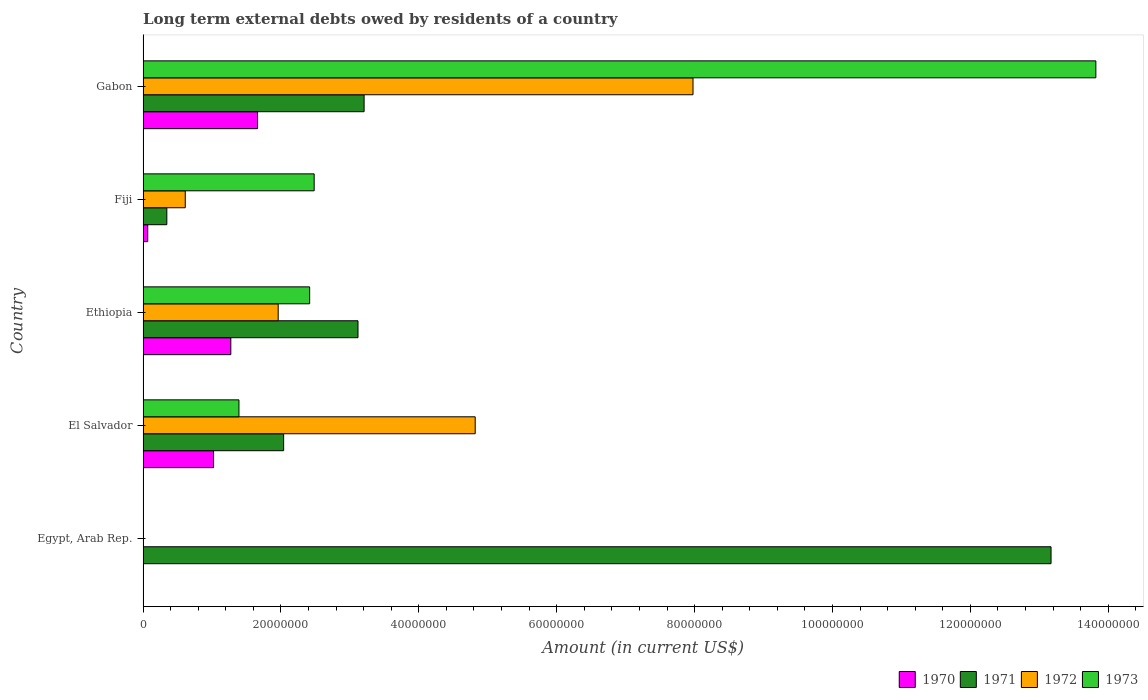Are the number of bars per tick equal to the number of legend labels?
Offer a terse response. No. How many bars are there on the 1st tick from the bottom?
Your answer should be very brief. 1. What is the label of the 4th group of bars from the top?
Provide a short and direct response. El Salvador. What is the amount of long-term external debts owed by residents in 1971 in Gabon?
Make the answer very short. 3.21e+07. Across all countries, what is the maximum amount of long-term external debts owed by residents in 1972?
Ensure brevity in your answer.  7.98e+07. In which country was the amount of long-term external debts owed by residents in 1971 maximum?
Your response must be concise. Egypt, Arab Rep. What is the total amount of long-term external debts owed by residents in 1972 in the graph?
Your answer should be very brief. 1.54e+08. What is the difference between the amount of long-term external debts owed by residents in 1972 in Fiji and that in Gabon?
Make the answer very short. -7.36e+07. What is the difference between the amount of long-term external debts owed by residents in 1971 in El Salvador and the amount of long-term external debts owed by residents in 1972 in Ethiopia?
Ensure brevity in your answer.  7.91e+05. What is the average amount of long-term external debts owed by residents in 1973 per country?
Provide a short and direct response. 4.02e+07. What is the difference between the amount of long-term external debts owed by residents in 1971 and amount of long-term external debts owed by residents in 1973 in Fiji?
Ensure brevity in your answer.  -2.14e+07. In how many countries, is the amount of long-term external debts owed by residents in 1970 greater than 116000000 US$?
Provide a succinct answer. 0. What is the ratio of the amount of long-term external debts owed by residents in 1972 in El Salvador to that in Fiji?
Offer a very short reply. 7.87. Is the difference between the amount of long-term external debts owed by residents in 1971 in Ethiopia and Gabon greater than the difference between the amount of long-term external debts owed by residents in 1973 in Ethiopia and Gabon?
Ensure brevity in your answer.  Yes. What is the difference between the highest and the second highest amount of long-term external debts owed by residents in 1973?
Make the answer very short. 1.13e+08. What is the difference between the highest and the lowest amount of long-term external debts owed by residents in 1973?
Your response must be concise. 1.38e+08. Is the sum of the amount of long-term external debts owed by residents in 1972 in El Salvador and Fiji greater than the maximum amount of long-term external debts owed by residents in 1973 across all countries?
Make the answer very short. No. Is it the case that in every country, the sum of the amount of long-term external debts owed by residents in 1973 and amount of long-term external debts owed by residents in 1971 is greater than the amount of long-term external debts owed by residents in 1972?
Your answer should be compact. No. How many bars are there?
Your response must be concise. 17. How many countries are there in the graph?
Ensure brevity in your answer.  5. Does the graph contain grids?
Offer a terse response. No. Where does the legend appear in the graph?
Your response must be concise. Bottom right. What is the title of the graph?
Provide a succinct answer. Long term external debts owed by residents of a country. Does "1993" appear as one of the legend labels in the graph?
Give a very brief answer. No. What is the Amount (in current US$) of 1971 in Egypt, Arab Rep.?
Provide a succinct answer. 1.32e+08. What is the Amount (in current US$) of 1973 in Egypt, Arab Rep.?
Give a very brief answer. 0. What is the Amount (in current US$) in 1970 in El Salvador?
Your answer should be very brief. 1.02e+07. What is the Amount (in current US$) in 1971 in El Salvador?
Your response must be concise. 2.04e+07. What is the Amount (in current US$) of 1972 in El Salvador?
Your answer should be very brief. 4.82e+07. What is the Amount (in current US$) of 1973 in El Salvador?
Offer a very short reply. 1.39e+07. What is the Amount (in current US$) in 1970 in Ethiopia?
Your response must be concise. 1.27e+07. What is the Amount (in current US$) of 1971 in Ethiopia?
Keep it short and to the point. 3.12e+07. What is the Amount (in current US$) in 1972 in Ethiopia?
Provide a short and direct response. 1.96e+07. What is the Amount (in current US$) in 1973 in Ethiopia?
Your answer should be compact. 2.42e+07. What is the Amount (in current US$) of 1970 in Fiji?
Give a very brief answer. 6.77e+05. What is the Amount (in current US$) in 1971 in Fiji?
Provide a short and direct response. 3.45e+06. What is the Amount (in current US$) in 1972 in Fiji?
Provide a succinct answer. 6.12e+06. What is the Amount (in current US$) of 1973 in Fiji?
Your response must be concise. 2.48e+07. What is the Amount (in current US$) of 1970 in Gabon?
Make the answer very short. 1.66e+07. What is the Amount (in current US$) of 1971 in Gabon?
Your answer should be compact. 3.21e+07. What is the Amount (in current US$) of 1972 in Gabon?
Your answer should be compact. 7.98e+07. What is the Amount (in current US$) of 1973 in Gabon?
Offer a terse response. 1.38e+08. Across all countries, what is the maximum Amount (in current US$) of 1970?
Provide a succinct answer. 1.66e+07. Across all countries, what is the maximum Amount (in current US$) of 1971?
Offer a very short reply. 1.32e+08. Across all countries, what is the maximum Amount (in current US$) in 1972?
Provide a short and direct response. 7.98e+07. Across all countries, what is the maximum Amount (in current US$) in 1973?
Ensure brevity in your answer.  1.38e+08. Across all countries, what is the minimum Amount (in current US$) of 1970?
Provide a short and direct response. 0. Across all countries, what is the minimum Amount (in current US$) of 1971?
Your answer should be very brief. 3.45e+06. What is the total Amount (in current US$) in 1970 in the graph?
Offer a very short reply. 4.02e+07. What is the total Amount (in current US$) of 1971 in the graph?
Your answer should be very brief. 2.19e+08. What is the total Amount (in current US$) in 1972 in the graph?
Give a very brief answer. 1.54e+08. What is the total Amount (in current US$) in 1973 in the graph?
Provide a short and direct response. 2.01e+08. What is the difference between the Amount (in current US$) of 1971 in Egypt, Arab Rep. and that in El Salvador?
Your answer should be very brief. 1.11e+08. What is the difference between the Amount (in current US$) of 1971 in Egypt, Arab Rep. and that in Ethiopia?
Make the answer very short. 1.01e+08. What is the difference between the Amount (in current US$) in 1971 in Egypt, Arab Rep. and that in Fiji?
Offer a terse response. 1.28e+08. What is the difference between the Amount (in current US$) of 1971 in Egypt, Arab Rep. and that in Gabon?
Offer a very short reply. 9.96e+07. What is the difference between the Amount (in current US$) in 1970 in El Salvador and that in Ethiopia?
Provide a succinct answer. -2.50e+06. What is the difference between the Amount (in current US$) of 1971 in El Salvador and that in Ethiopia?
Provide a succinct answer. -1.08e+07. What is the difference between the Amount (in current US$) of 1972 in El Salvador and that in Ethiopia?
Provide a short and direct response. 2.86e+07. What is the difference between the Amount (in current US$) of 1973 in El Salvador and that in Ethiopia?
Make the answer very short. -1.03e+07. What is the difference between the Amount (in current US$) of 1970 in El Salvador and that in Fiji?
Keep it short and to the point. 9.55e+06. What is the difference between the Amount (in current US$) of 1971 in El Salvador and that in Fiji?
Give a very brief answer. 1.69e+07. What is the difference between the Amount (in current US$) of 1972 in El Salvador and that in Fiji?
Your answer should be very brief. 4.21e+07. What is the difference between the Amount (in current US$) of 1973 in El Salvador and that in Fiji?
Your response must be concise. -1.09e+07. What is the difference between the Amount (in current US$) of 1970 in El Salvador and that in Gabon?
Provide a succinct answer. -6.38e+06. What is the difference between the Amount (in current US$) in 1971 in El Salvador and that in Gabon?
Your answer should be very brief. -1.17e+07. What is the difference between the Amount (in current US$) of 1972 in El Salvador and that in Gabon?
Offer a very short reply. -3.16e+07. What is the difference between the Amount (in current US$) in 1973 in El Salvador and that in Gabon?
Offer a very short reply. -1.24e+08. What is the difference between the Amount (in current US$) in 1970 in Ethiopia and that in Fiji?
Provide a short and direct response. 1.20e+07. What is the difference between the Amount (in current US$) in 1971 in Ethiopia and that in Fiji?
Keep it short and to the point. 2.77e+07. What is the difference between the Amount (in current US$) of 1972 in Ethiopia and that in Fiji?
Make the answer very short. 1.35e+07. What is the difference between the Amount (in current US$) in 1973 in Ethiopia and that in Fiji?
Provide a short and direct response. -6.56e+05. What is the difference between the Amount (in current US$) in 1970 in Ethiopia and that in Gabon?
Provide a succinct answer. -3.88e+06. What is the difference between the Amount (in current US$) in 1971 in Ethiopia and that in Gabon?
Make the answer very short. -8.88e+05. What is the difference between the Amount (in current US$) in 1972 in Ethiopia and that in Gabon?
Your answer should be very brief. -6.02e+07. What is the difference between the Amount (in current US$) of 1973 in Ethiopia and that in Gabon?
Make the answer very short. -1.14e+08. What is the difference between the Amount (in current US$) in 1970 in Fiji and that in Gabon?
Give a very brief answer. -1.59e+07. What is the difference between the Amount (in current US$) in 1971 in Fiji and that in Gabon?
Ensure brevity in your answer.  -2.86e+07. What is the difference between the Amount (in current US$) of 1972 in Fiji and that in Gabon?
Provide a succinct answer. -7.36e+07. What is the difference between the Amount (in current US$) of 1973 in Fiji and that in Gabon?
Give a very brief answer. -1.13e+08. What is the difference between the Amount (in current US$) of 1971 in Egypt, Arab Rep. and the Amount (in current US$) of 1972 in El Salvador?
Provide a succinct answer. 8.35e+07. What is the difference between the Amount (in current US$) of 1971 in Egypt, Arab Rep. and the Amount (in current US$) of 1973 in El Salvador?
Make the answer very short. 1.18e+08. What is the difference between the Amount (in current US$) of 1971 in Egypt, Arab Rep. and the Amount (in current US$) of 1972 in Ethiopia?
Provide a short and direct response. 1.12e+08. What is the difference between the Amount (in current US$) of 1971 in Egypt, Arab Rep. and the Amount (in current US$) of 1973 in Ethiopia?
Give a very brief answer. 1.08e+08. What is the difference between the Amount (in current US$) of 1971 in Egypt, Arab Rep. and the Amount (in current US$) of 1972 in Fiji?
Your answer should be compact. 1.26e+08. What is the difference between the Amount (in current US$) in 1971 in Egypt, Arab Rep. and the Amount (in current US$) in 1973 in Fiji?
Your answer should be very brief. 1.07e+08. What is the difference between the Amount (in current US$) in 1971 in Egypt, Arab Rep. and the Amount (in current US$) in 1972 in Gabon?
Ensure brevity in your answer.  5.19e+07. What is the difference between the Amount (in current US$) of 1971 in Egypt, Arab Rep. and the Amount (in current US$) of 1973 in Gabon?
Offer a very short reply. -6.50e+06. What is the difference between the Amount (in current US$) in 1970 in El Salvador and the Amount (in current US$) in 1971 in Ethiopia?
Your answer should be very brief. -2.09e+07. What is the difference between the Amount (in current US$) of 1970 in El Salvador and the Amount (in current US$) of 1972 in Ethiopia?
Your answer should be very brief. -9.37e+06. What is the difference between the Amount (in current US$) of 1970 in El Salvador and the Amount (in current US$) of 1973 in Ethiopia?
Your answer should be compact. -1.39e+07. What is the difference between the Amount (in current US$) in 1971 in El Salvador and the Amount (in current US$) in 1972 in Ethiopia?
Provide a succinct answer. 7.91e+05. What is the difference between the Amount (in current US$) in 1971 in El Salvador and the Amount (in current US$) in 1973 in Ethiopia?
Offer a terse response. -3.77e+06. What is the difference between the Amount (in current US$) in 1972 in El Salvador and the Amount (in current US$) in 1973 in Ethiopia?
Your response must be concise. 2.40e+07. What is the difference between the Amount (in current US$) of 1970 in El Salvador and the Amount (in current US$) of 1971 in Fiji?
Your answer should be very brief. 6.78e+06. What is the difference between the Amount (in current US$) in 1970 in El Salvador and the Amount (in current US$) in 1972 in Fiji?
Make the answer very short. 4.10e+06. What is the difference between the Amount (in current US$) of 1970 in El Salvador and the Amount (in current US$) of 1973 in Fiji?
Your response must be concise. -1.46e+07. What is the difference between the Amount (in current US$) of 1971 in El Salvador and the Amount (in current US$) of 1972 in Fiji?
Keep it short and to the point. 1.43e+07. What is the difference between the Amount (in current US$) of 1971 in El Salvador and the Amount (in current US$) of 1973 in Fiji?
Ensure brevity in your answer.  -4.43e+06. What is the difference between the Amount (in current US$) in 1972 in El Salvador and the Amount (in current US$) in 1973 in Fiji?
Make the answer very short. 2.34e+07. What is the difference between the Amount (in current US$) in 1970 in El Salvador and the Amount (in current US$) in 1971 in Gabon?
Your response must be concise. -2.18e+07. What is the difference between the Amount (in current US$) of 1970 in El Salvador and the Amount (in current US$) of 1972 in Gabon?
Provide a short and direct response. -6.95e+07. What is the difference between the Amount (in current US$) of 1970 in El Salvador and the Amount (in current US$) of 1973 in Gabon?
Ensure brevity in your answer.  -1.28e+08. What is the difference between the Amount (in current US$) in 1971 in El Salvador and the Amount (in current US$) in 1972 in Gabon?
Provide a succinct answer. -5.94e+07. What is the difference between the Amount (in current US$) of 1971 in El Salvador and the Amount (in current US$) of 1973 in Gabon?
Offer a very short reply. -1.18e+08. What is the difference between the Amount (in current US$) of 1972 in El Salvador and the Amount (in current US$) of 1973 in Gabon?
Provide a short and direct response. -9.00e+07. What is the difference between the Amount (in current US$) in 1970 in Ethiopia and the Amount (in current US$) in 1971 in Fiji?
Provide a short and direct response. 9.28e+06. What is the difference between the Amount (in current US$) in 1970 in Ethiopia and the Amount (in current US$) in 1972 in Fiji?
Offer a terse response. 6.61e+06. What is the difference between the Amount (in current US$) in 1970 in Ethiopia and the Amount (in current US$) in 1973 in Fiji?
Keep it short and to the point. -1.21e+07. What is the difference between the Amount (in current US$) in 1971 in Ethiopia and the Amount (in current US$) in 1972 in Fiji?
Give a very brief answer. 2.51e+07. What is the difference between the Amount (in current US$) of 1971 in Ethiopia and the Amount (in current US$) of 1973 in Fiji?
Provide a short and direct response. 6.36e+06. What is the difference between the Amount (in current US$) in 1972 in Ethiopia and the Amount (in current US$) in 1973 in Fiji?
Your answer should be very brief. -5.22e+06. What is the difference between the Amount (in current US$) in 1970 in Ethiopia and the Amount (in current US$) in 1971 in Gabon?
Ensure brevity in your answer.  -1.93e+07. What is the difference between the Amount (in current US$) of 1970 in Ethiopia and the Amount (in current US$) of 1972 in Gabon?
Offer a terse response. -6.70e+07. What is the difference between the Amount (in current US$) in 1970 in Ethiopia and the Amount (in current US$) in 1973 in Gabon?
Make the answer very short. -1.25e+08. What is the difference between the Amount (in current US$) of 1971 in Ethiopia and the Amount (in current US$) of 1972 in Gabon?
Keep it short and to the point. -4.86e+07. What is the difference between the Amount (in current US$) of 1971 in Ethiopia and the Amount (in current US$) of 1973 in Gabon?
Your answer should be compact. -1.07e+08. What is the difference between the Amount (in current US$) in 1972 in Ethiopia and the Amount (in current US$) in 1973 in Gabon?
Your response must be concise. -1.19e+08. What is the difference between the Amount (in current US$) of 1970 in Fiji and the Amount (in current US$) of 1971 in Gabon?
Keep it short and to the point. -3.14e+07. What is the difference between the Amount (in current US$) of 1970 in Fiji and the Amount (in current US$) of 1972 in Gabon?
Offer a very short reply. -7.91e+07. What is the difference between the Amount (in current US$) of 1970 in Fiji and the Amount (in current US$) of 1973 in Gabon?
Keep it short and to the point. -1.38e+08. What is the difference between the Amount (in current US$) in 1971 in Fiji and the Amount (in current US$) in 1972 in Gabon?
Keep it short and to the point. -7.63e+07. What is the difference between the Amount (in current US$) of 1971 in Fiji and the Amount (in current US$) of 1973 in Gabon?
Keep it short and to the point. -1.35e+08. What is the difference between the Amount (in current US$) in 1972 in Fiji and the Amount (in current US$) in 1973 in Gabon?
Make the answer very short. -1.32e+08. What is the average Amount (in current US$) in 1970 per country?
Offer a very short reply. 8.05e+06. What is the average Amount (in current US$) of 1971 per country?
Offer a terse response. 4.38e+07. What is the average Amount (in current US$) in 1972 per country?
Keep it short and to the point. 3.07e+07. What is the average Amount (in current US$) in 1973 per country?
Ensure brevity in your answer.  4.02e+07. What is the difference between the Amount (in current US$) in 1970 and Amount (in current US$) in 1971 in El Salvador?
Provide a short and direct response. -1.02e+07. What is the difference between the Amount (in current US$) in 1970 and Amount (in current US$) in 1972 in El Salvador?
Keep it short and to the point. -3.79e+07. What is the difference between the Amount (in current US$) of 1970 and Amount (in current US$) of 1973 in El Salvador?
Make the answer very short. -3.68e+06. What is the difference between the Amount (in current US$) in 1971 and Amount (in current US$) in 1972 in El Salvador?
Give a very brief answer. -2.78e+07. What is the difference between the Amount (in current US$) in 1971 and Amount (in current US$) in 1973 in El Salvador?
Provide a short and direct response. 6.48e+06. What is the difference between the Amount (in current US$) in 1972 and Amount (in current US$) in 1973 in El Salvador?
Keep it short and to the point. 3.43e+07. What is the difference between the Amount (in current US$) of 1970 and Amount (in current US$) of 1971 in Ethiopia?
Your answer should be very brief. -1.84e+07. What is the difference between the Amount (in current US$) of 1970 and Amount (in current US$) of 1972 in Ethiopia?
Ensure brevity in your answer.  -6.87e+06. What is the difference between the Amount (in current US$) in 1970 and Amount (in current US$) in 1973 in Ethiopia?
Your answer should be very brief. -1.14e+07. What is the difference between the Amount (in current US$) in 1971 and Amount (in current US$) in 1972 in Ethiopia?
Keep it short and to the point. 1.16e+07. What is the difference between the Amount (in current US$) in 1971 and Amount (in current US$) in 1973 in Ethiopia?
Provide a short and direct response. 7.01e+06. What is the difference between the Amount (in current US$) in 1972 and Amount (in current US$) in 1973 in Ethiopia?
Offer a terse response. -4.56e+06. What is the difference between the Amount (in current US$) of 1970 and Amount (in current US$) of 1971 in Fiji?
Make the answer very short. -2.77e+06. What is the difference between the Amount (in current US$) of 1970 and Amount (in current US$) of 1972 in Fiji?
Keep it short and to the point. -5.44e+06. What is the difference between the Amount (in current US$) in 1970 and Amount (in current US$) in 1973 in Fiji?
Offer a very short reply. -2.41e+07. What is the difference between the Amount (in current US$) in 1971 and Amount (in current US$) in 1972 in Fiji?
Keep it short and to the point. -2.68e+06. What is the difference between the Amount (in current US$) of 1971 and Amount (in current US$) of 1973 in Fiji?
Your answer should be compact. -2.14e+07. What is the difference between the Amount (in current US$) in 1972 and Amount (in current US$) in 1973 in Fiji?
Give a very brief answer. -1.87e+07. What is the difference between the Amount (in current US$) in 1970 and Amount (in current US$) in 1971 in Gabon?
Keep it short and to the point. -1.55e+07. What is the difference between the Amount (in current US$) of 1970 and Amount (in current US$) of 1972 in Gabon?
Keep it short and to the point. -6.32e+07. What is the difference between the Amount (in current US$) of 1970 and Amount (in current US$) of 1973 in Gabon?
Give a very brief answer. -1.22e+08. What is the difference between the Amount (in current US$) in 1971 and Amount (in current US$) in 1972 in Gabon?
Your answer should be compact. -4.77e+07. What is the difference between the Amount (in current US$) of 1971 and Amount (in current US$) of 1973 in Gabon?
Make the answer very short. -1.06e+08. What is the difference between the Amount (in current US$) in 1972 and Amount (in current US$) in 1973 in Gabon?
Keep it short and to the point. -5.84e+07. What is the ratio of the Amount (in current US$) in 1971 in Egypt, Arab Rep. to that in El Salvador?
Give a very brief answer. 6.46. What is the ratio of the Amount (in current US$) in 1971 in Egypt, Arab Rep. to that in Ethiopia?
Give a very brief answer. 4.22. What is the ratio of the Amount (in current US$) of 1971 in Egypt, Arab Rep. to that in Fiji?
Give a very brief answer. 38.22. What is the ratio of the Amount (in current US$) of 1971 in Egypt, Arab Rep. to that in Gabon?
Provide a short and direct response. 4.11. What is the ratio of the Amount (in current US$) of 1970 in El Salvador to that in Ethiopia?
Your answer should be compact. 0.8. What is the ratio of the Amount (in current US$) in 1971 in El Salvador to that in Ethiopia?
Provide a succinct answer. 0.65. What is the ratio of the Amount (in current US$) of 1972 in El Salvador to that in Ethiopia?
Offer a terse response. 2.46. What is the ratio of the Amount (in current US$) in 1973 in El Salvador to that in Ethiopia?
Provide a succinct answer. 0.58. What is the ratio of the Amount (in current US$) in 1970 in El Salvador to that in Fiji?
Your answer should be compact. 15.1. What is the ratio of the Amount (in current US$) in 1971 in El Salvador to that in Fiji?
Your answer should be compact. 5.92. What is the ratio of the Amount (in current US$) of 1972 in El Salvador to that in Fiji?
Provide a succinct answer. 7.87. What is the ratio of the Amount (in current US$) of 1973 in El Salvador to that in Fiji?
Your answer should be compact. 0.56. What is the ratio of the Amount (in current US$) of 1970 in El Salvador to that in Gabon?
Make the answer very short. 0.62. What is the ratio of the Amount (in current US$) in 1971 in El Salvador to that in Gabon?
Your response must be concise. 0.64. What is the ratio of the Amount (in current US$) in 1972 in El Salvador to that in Gabon?
Give a very brief answer. 0.6. What is the ratio of the Amount (in current US$) of 1973 in El Salvador to that in Gabon?
Provide a succinct answer. 0.1. What is the ratio of the Amount (in current US$) of 1970 in Ethiopia to that in Fiji?
Make the answer very short. 18.8. What is the ratio of the Amount (in current US$) of 1971 in Ethiopia to that in Fiji?
Your answer should be very brief. 9.05. What is the ratio of the Amount (in current US$) in 1972 in Ethiopia to that in Fiji?
Give a very brief answer. 3.2. What is the ratio of the Amount (in current US$) in 1973 in Ethiopia to that in Fiji?
Your answer should be compact. 0.97. What is the ratio of the Amount (in current US$) in 1970 in Ethiopia to that in Gabon?
Make the answer very short. 0.77. What is the ratio of the Amount (in current US$) of 1971 in Ethiopia to that in Gabon?
Offer a terse response. 0.97. What is the ratio of the Amount (in current US$) in 1972 in Ethiopia to that in Gabon?
Provide a succinct answer. 0.25. What is the ratio of the Amount (in current US$) in 1973 in Ethiopia to that in Gabon?
Provide a short and direct response. 0.17. What is the ratio of the Amount (in current US$) in 1970 in Fiji to that in Gabon?
Your answer should be compact. 0.04. What is the ratio of the Amount (in current US$) of 1971 in Fiji to that in Gabon?
Provide a short and direct response. 0.11. What is the ratio of the Amount (in current US$) of 1972 in Fiji to that in Gabon?
Provide a short and direct response. 0.08. What is the ratio of the Amount (in current US$) of 1973 in Fiji to that in Gabon?
Provide a short and direct response. 0.18. What is the difference between the highest and the second highest Amount (in current US$) in 1970?
Give a very brief answer. 3.88e+06. What is the difference between the highest and the second highest Amount (in current US$) in 1971?
Provide a succinct answer. 9.96e+07. What is the difference between the highest and the second highest Amount (in current US$) of 1972?
Your response must be concise. 3.16e+07. What is the difference between the highest and the second highest Amount (in current US$) of 1973?
Ensure brevity in your answer.  1.13e+08. What is the difference between the highest and the lowest Amount (in current US$) of 1970?
Offer a very short reply. 1.66e+07. What is the difference between the highest and the lowest Amount (in current US$) of 1971?
Your answer should be compact. 1.28e+08. What is the difference between the highest and the lowest Amount (in current US$) of 1972?
Your answer should be compact. 7.98e+07. What is the difference between the highest and the lowest Amount (in current US$) of 1973?
Provide a succinct answer. 1.38e+08. 